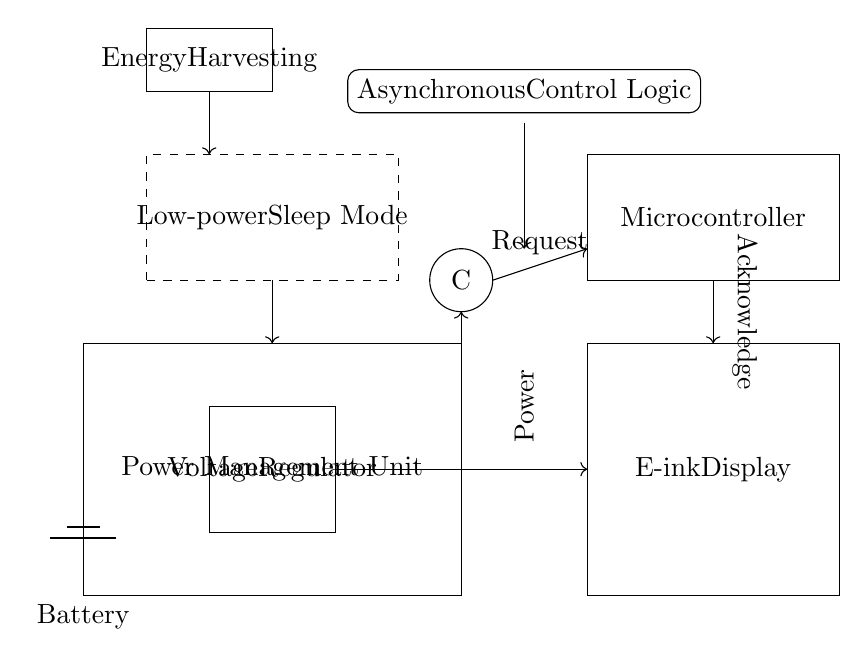What is the main function of the Power Management Unit? The Power Management Unit regulates the power supply to the various components, ensuring they receive the appropriate voltage and current for operation.
Answer: Regulates Power Which component initiates the power request? The Microcontroller is the component that initiates the power request, sending a signal to the power management unit when power is needed.
Answer: Microcontroller What does the 'C' in the circle represent? The 'C' represents a Muller C-element, which is used for asynchronous operations in the circuit, allowing the system to manage signals without a global clock.
Answer: Muller C-element How does the circuit enter Low-power Sleep Mode? The circuit enters Sleep Mode by the Microcontroller sending a control signal to the Power Management Unit, indicated by the dashed rectangle in the diagram.
Answer: Control Signal What type of energy does the Energy Harvesting unit collect? The Energy Harvesting unit collects ambient energy, which can be converted into electrical energy to support the circuit operation and recharge the battery.
Answer: Ambient Energy What does the Acknowledge arrow indicate? The Acknowledge arrow indicates a response signal from the Power Management Unit, confirming that the power request from the Microcontroller has been received and acted upon.
Answer: Response Signal How many components are shown in the circuit? The circuit diagram includes six main components: Battery, Voltage Regulator, E-ink Display, Microcontroller, Muller C-element, and Energy Harvesting unit.
Answer: Six Components 